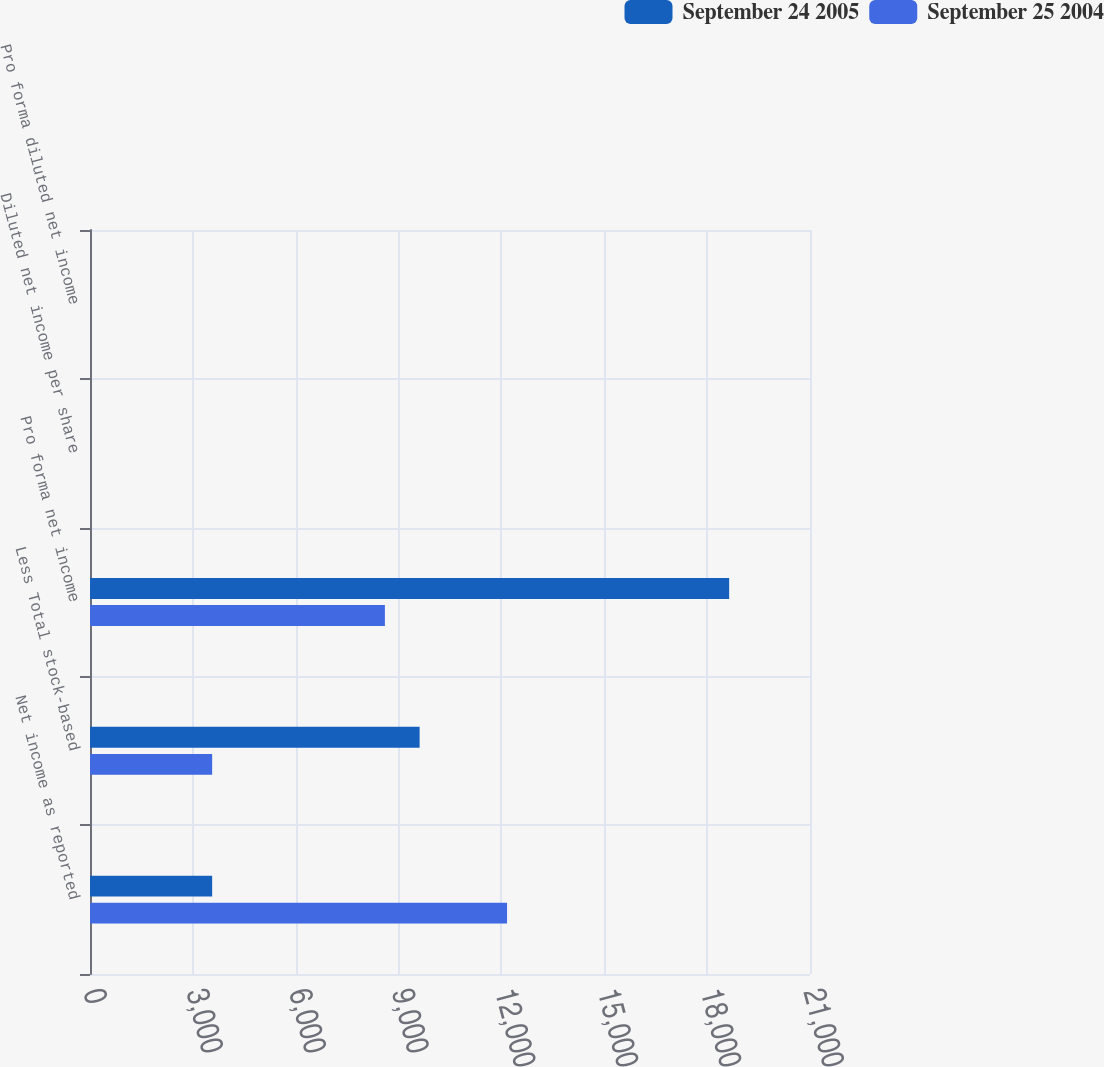Convert chart to OTSL. <chart><loc_0><loc_0><loc_500><loc_500><stacked_bar_chart><ecel><fcel>Net income as reported<fcel>Less Total stock-based<fcel>Pro forma net income<fcel>Diluted net income per share<fcel>Pro forma diluted net income<nl><fcel>September 24 2005<fcel>3563<fcel>9614<fcel>18642<fcel>0.63<fcel>0.41<nl><fcel>September 25 2004<fcel>12164<fcel>3563<fcel>8601<fcel>0.29<fcel>0.2<nl></chart> 